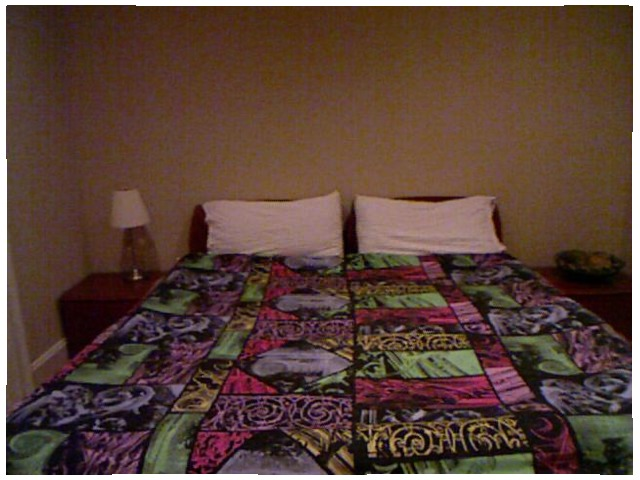<image>
Can you confirm if the pillow is to the left of the pillow? Yes. From this viewpoint, the pillow is positioned to the left side relative to the pillow. Is there a pillow under the blanket? No. The pillow is not positioned under the blanket. The vertical relationship between these objects is different. Where is the light in relation to the bed? Is it next to the bed? Yes. The light is positioned adjacent to the bed, located nearby in the same general area. Where is the wall in relation to the pillow? Is it behind the pillow? Yes. From this viewpoint, the wall is positioned behind the pillow, with the pillow partially or fully occluding the wall. 